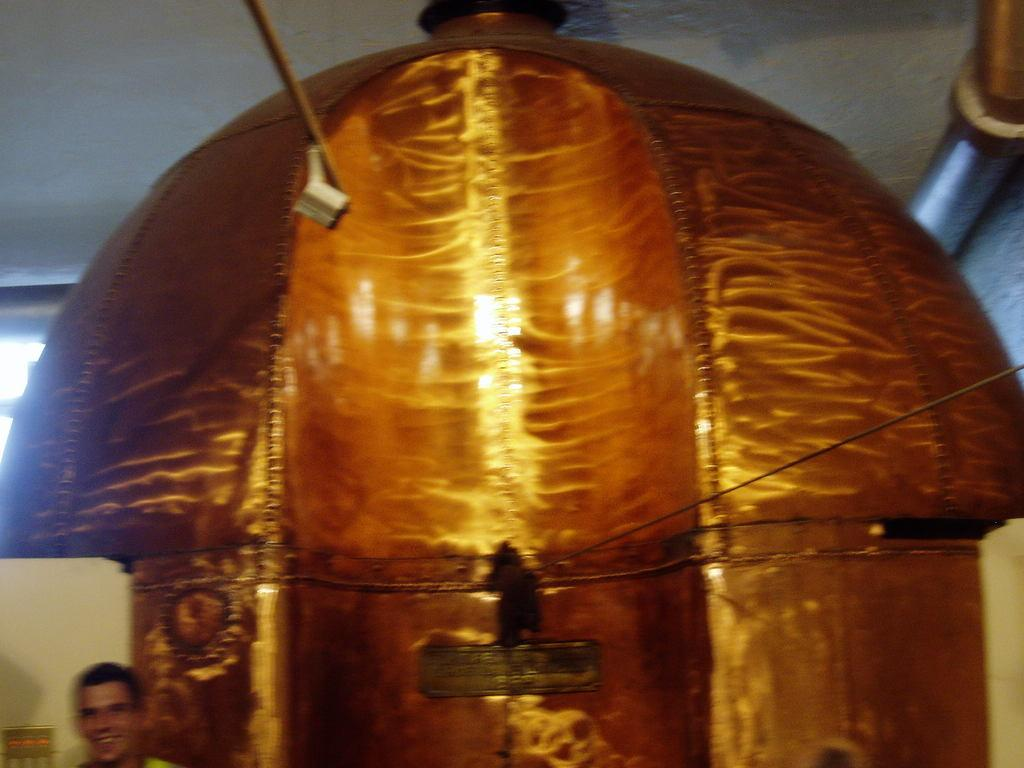What is the main subject in the image? There is an object in the image. Can you describe the appearance of the object? The object is in golden color. Is there anyone present in relation to the object? Yes, there is a person standing near the object. Can you tell me how many kites are being sold at the market in the image? There is no market or kites present in the image; it features an object in golden color and a person standing near it. What type of tin is being used to store the object in the image? There is no tin present in the image; the object's material is not specified. 